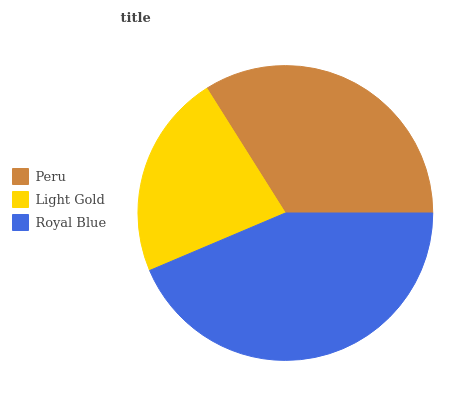Is Light Gold the minimum?
Answer yes or no. Yes. Is Royal Blue the maximum?
Answer yes or no. Yes. Is Royal Blue the minimum?
Answer yes or no. No. Is Light Gold the maximum?
Answer yes or no. No. Is Royal Blue greater than Light Gold?
Answer yes or no. Yes. Is Light Gold less than Royal Blue?
Answer yes or no. Yes. Is Light Gold greater than Royal Blue?
Answer yes or no. No. Is Royal Blue less than Light Gold?
Answer yes or no. No. Is Peru the high median?
Answer yes or no. Yes. Is Peru the low median?
Answer yes or no. Yes. Is Royal Blue the high median?
Answer yes or no. No. Is Royal Blue the low median?
Answer yes or no. No. 